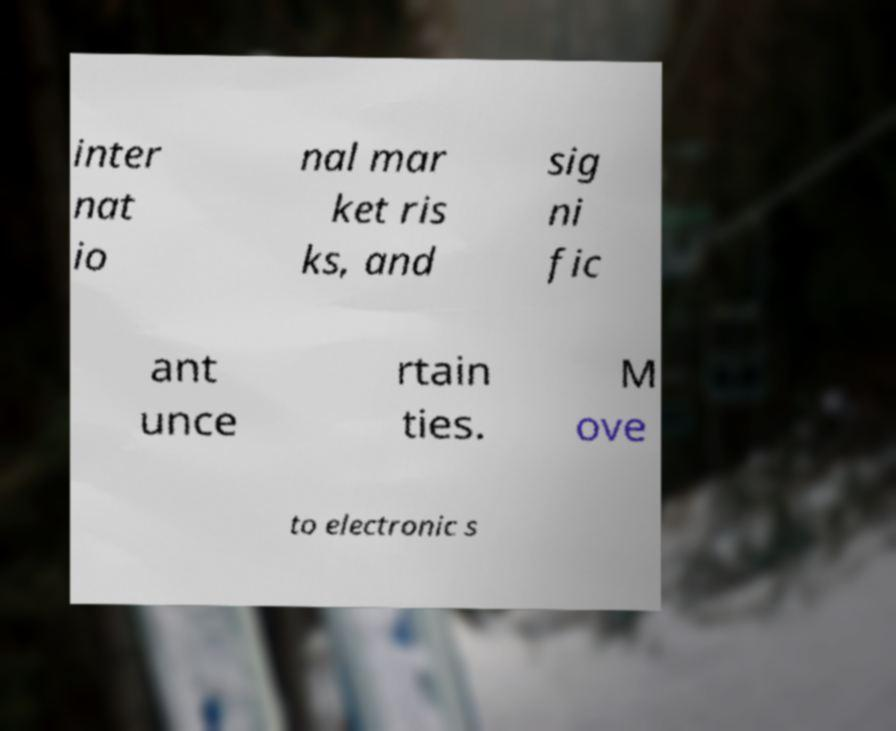Could you assist in decoding the text presented in this image and type it out clearly? inter nat io nal mar ket ris ks, and sig ni fic ant unce rtain ties. M ove to electronic s 